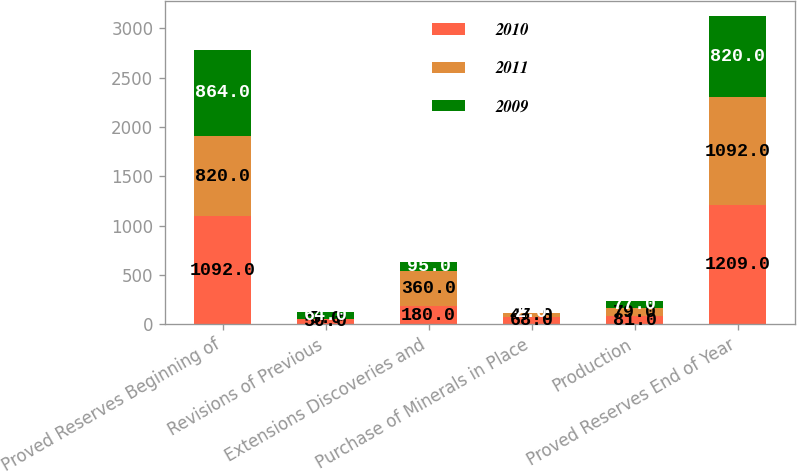<chart> <loc_0><loc_0><loc_500><loc_500><stacked_bar_chart><ecel><fcel>Proved Reserves Beginning of<fcel>Revisions of Previous<fcel>Extensions Discoveries and<fcel>Purchase of Minerals in Place<fcel>Production<fcel>Proved Reserves End of Year<nl><fcel>2010<fcel>1092<fcel>50<fcel>180<fcel>68<fcel>81<fcel>1209<nl><fcel>2011<fcel>820<fcel>5<fcel>360<fcel>47<fcel>79<fcel>1092<nl><fcel>2009<fcel>864<fcel>64<fcel>95<fcel>2<fcel>77<fcel>820<nl></chart> 